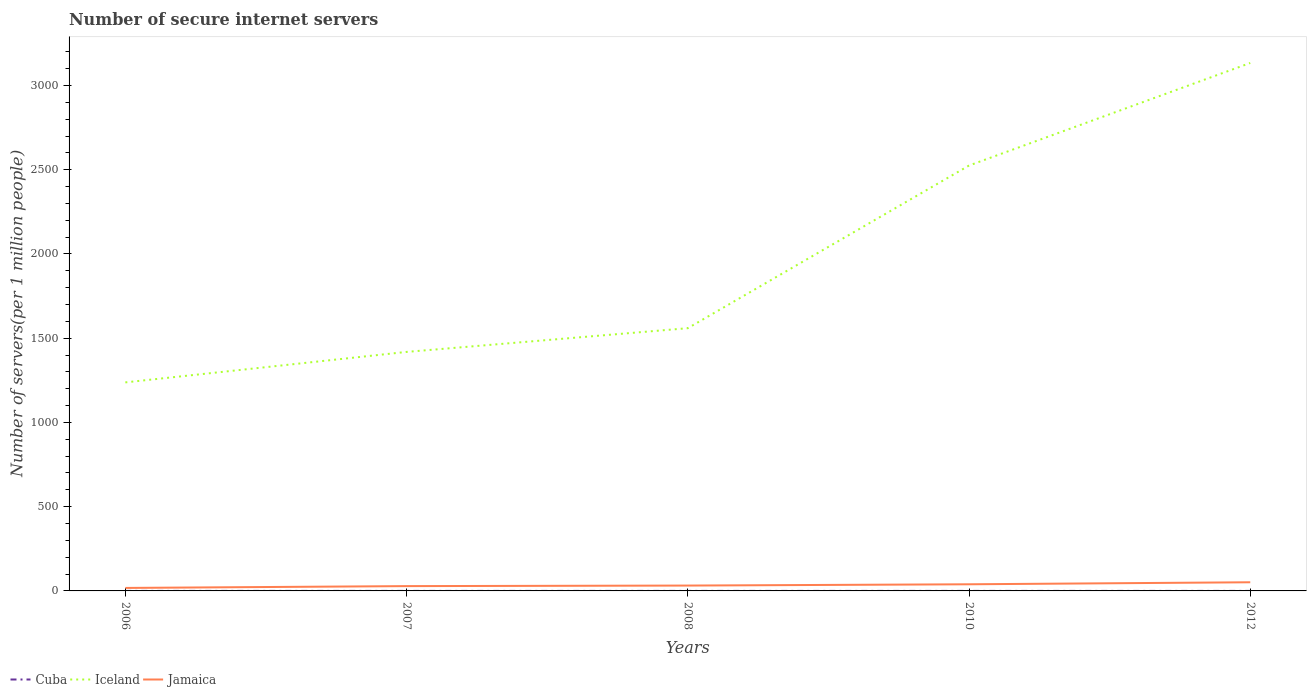How many different coloured lines are there?
Make the answer very short. 3. Is the number of lines equal to the number of legend labels?
Your answer should be compact. Yes. Across all years, what is the maximum number of secure internet servers in Iceland?
Keep it short and to the point. 1237.73. What is the total number of secure internet servers in Jamaica in the graph?
Your response must be concise. -3.27. What is the difference between the highest and the second highest number of secure internet servers in Cuba?
Provide a succinct answer. 0. What is the difference between two consecutive major ticks on the Y-axis?
Provide a short and direct response. 500. Where does the legend appear in the graph?
Keep it short and to the point. Bottom left. How are the legend labels stacked?
Ensure brevity in your answer.  Horizontal. What is the title of the graph?
Make the answer very short. Number of secure internet servers. What is the label or title of the Y-axis?
Your answer should be compact. Number of servers(per 1 million people). What is the Number of servers(per 1 million people) in Cuba in 2006?
Your answer should be compact. 0.09. What is the Number of servers(per 1 million people) in Iceland in 2006?
Offer a terse response. 1237.73. What is the Number of servers(per 1 million people) of Jamaica in 2006?
Your answer should be very brief. 17.72. What is the Number of servers(per 1 million people) in Cuba in 2007?
Give a very brief answer. 0.09. What is the Number of servers(per 1 million people) of Iceland in 2007?
Offer a terse response. 1418.64. What is the Number of servers(per 1 million people) of Jamaica in 2007?
Your answer should be very brief. 28.54. What is the Number of servers(per 1 million people) in Cuba in 2008?
Your answer should be very brief. 0.09. What is the Number of servers(per 1 million people) of Iceland in 2008?
Keep it short and to the point. 1559.48. What is the Number of servers(per 1 million people) in Jamaica in 2008?
Make the answer very short. 31.81. What is the Number of servers(per 1 million people) of Cuba in 2010?
Your answer should be very brief. 0.09. What is the Number of servers(per 1 million people) of Iceland in 2010?
Your response must be concise. 2524.83. What is the Number of servers(per 1 million people) of Jamaica in 2010?
Make the answer very short. 39.39. What is the Number of servers(per 1 million people) of Cuba in 2012?
Give a very brief answer. 0.09. What is the Number of servers(per 1 million people) of Iceland in 2012?
Your answer should be compact. 3133.61. What is the Number of servers(per 1 million people) in Jamaica in 2012?
Provide a succinct answer. 51.33. Across all years, what is the maximum Number of servers(per 1 million people) in Cuba?
Provide a short and direct response. 0.09. Across all years, what is the maximum Number of servers(per 1 million people) in Iceland?
Offer a very short reply. 3133.61. Across all years, what is the maximum Number of servers(per 1 million people) of Jamaica?
Your answer should be compact. 51.33. Across all years, what is the minimum Number of servers(per 1 million people) of Cuba?
Your answer should be very brief. 0.09. Across all years, what is the minimum Number of servers(per 1 million people) of Iceland?
Provide a short and direct response. 1237.73. Across all years, what is the minimum Number of servers(per 1 million people) of Jamaica?
Offer a terse response. 17.72. What is the total Number of servers(per 1 million people) of Cuba in the graph?
Give a very brief answer. 0.44. What is the total Number of servers(per 1 million people) of Iceland in the graph?
Give a very brief answer. 9874.29. What is the total Number of servers(per 1 million people) in Jamaica in the graph?
Your answer should be very brief. 168.8. What is the difference between the Number of servers(per 1 million people) in Cuba in 2006 and that in 2007?
Your answer should be compact. 0. What is the difference between the Number of servers(per 1 million people) in Iceland in 2006 and that in 2007?
Keep it short and to the point. -180.91. What is the difference between the Number of servers(per 1 million people) in Jamaica in 2006 and that in 2007?
Your response must be concise. -10.83. What is the difference between the Number of servers(per 1 million people) in Iceland in 2006 and that in 2008?
Your answer should be very brief. -321.75. What is the difference between the Number of servers(per 1 million people) of Jamaica in 2006 and that in 2008?
Ensure brevity in your answer.  -14.1. What is the difference between the Number of servers(per 1 million people) in Iceland in 2006 and that in 2010?
Offer a terse response. -1287.1. What is the difference between the Number of servers(per 1 million people) of Jamaica in 2006 and that in 2010?
Make the answer very short. -21.68. What is the difference between the Number of servers(per 1 million people) in Cuba in 2006 and that in 2012?
Your response must be concise. 0. What is the difference between the Number of servers(per 1 million people) in Iceland in 2006 and that in 2012?
Your answer should be compact. -1895.88. What is the difference between the Number of servers(per 1 million people) in Jamaica in 2006 and that in 2012?
Ensure brevity in your answer.  -33.62. What is the difference between the Number of servers(per 1 million people) in Cuba in 2007 and that in 2008?
Give a very brief answer. 0. What is the difference between the Number of servers(per 1 million people) of Iceland in 2007 and that in 2008?
Ensure brevity in your answer.  -140.84. What is the difference between the Number of servers(per 1 million people) of Jamaica in 2007 and that in 2008?
Provide a short and direct response. -3.27. What is the difference between the Number of servers(per 1 million people) of Cuba in 2007 and that in 2010?
Make the answer very short. 0. What is the difference between the Number of servers(per 1 million people) in Iceland in 2007 and that in 2010?
Ensure brevity in your answer.  -1106.19. What is the difference between the Number of servers(per 1 million people) of Jamaica in 2007 and that in 2010?
Your answer should be compact. -10.85. What is the difference between the Number of servers(per 1 million people) of Cuba in 2007 and that in 2012?
Your answer should be very brief. 0. What is the difference between the Number of servers(per 1 million people) in Iceland in 2007 and that in 2012?
Ensure brevity in your answer.  -1714.97. What is the difference between the Number of servers(per 1 million people) in Jamaica in 2007 and that in 2012?
Offer a terse response. -22.79. What is the difference between the Number of servers(per 1 million people) of Cuba in 2008 and that in 2010?
Offer a very short reply. 0. What is the difference between the Number of servers(per 1 million people) in Iceland in 2008 and that in 2010?
Offer a very short reply. -965.35. What is the difference between the Number of servers(per 1 million people) in Jamaica in 2008 and that in 2010?
Make the answer very short. -7.58. What is the difference between the Number of servers(per 1 million people) in Cuba in 2008 and that in 2012?
Your answer should be compact. 0. What is the difference between the Number of servers(per 1 million people) of Iceland in 2008 and that in 2012?
Your answer should be very brief. -1574.14. What is the difference between the Number of servers(per 1 million people) in Jamaica in 2008 and that in 2012?
Keep it short and to the point. -19.52. What is the difference between the Number of servers(per 1 million people) of Iceland in 2010 and that in 2012?
Give a very brief answer. -608.78. What is the difference between the Number of servers(per 1 million people) of Jamaica in 2010 and that in 2012?
Your answer should be very brief. -11.94. What is the difference between the Number of servers(per 1 million people) of Cuba in 2006 and the Number of servers(per 1 million people) of Iceland in 2007?
Ensure brevity in your answer.  -1418.55. What is the difference between the Number of servers(per 1 million people) in Cuba in 2006 and the Number of servers(per 1 million people) in Jamaica in 2007?
Offer a very short reply. -28.46. What is the difference between the Number of servers(per 1 million people) in Iceland in 2006 and the Number of servers(per 1 million people) in Jamaica in 2007?
Keep it short and to the point. 1209.18. What is the difference between the Number of servers(per 1 million people) in Cuba in 2006 and the Number of servers(per 1 million people) in Iceland in 2008?
Make the answer very short. -1559.39. What is the difference between the Number of servers(per 1 million people) in Cuba in 2006 and the Number of servers(per 1 million people) in Jamaica in 2008?
Make the answer very short. -31.72. What is the difference between the Number of servers(per 1 million people) of Iceland in 2006 and the Number of servers(per 1 million people) of Jamaica in 2008?
Your response must be concise. 1205.92. What is the difference between the Number of servers(per 1 million people) in Cuba in 2006 and the Number of servers(per 1 million people) in Iceland in 2010?
Ensure brevity in your answer.  -2524.74. What is the difference between the Number of servers(per 1 million people) of Cuba in 2006 and the Number of servers(per 1 million people) of Jamaica in 2010?
Ensure brevity in your answer.  -39.3. What is the difference between the Number of servers(per 1 million people) in Iceland in 2006 and the Number of servers(per 1 million people) in Jamaica in 2010?
Offer a very short reply. 1198.34. What is the difference between the Number of servers(per 1 million people) in Cuba in 2006 and the Number of servers(per 1 million people) in Iceland in 2012?
Give a very brief answer. -3133.52. What is the difference between the Number of servers(per 1 million people) in Cuba in 2006 and the Number of servers(per 1 million people) in Jamaica in 2012?
Provide a succinct answer. -51.24. What is the difference between the Number of servers(per 1 million people) of Iceland in 2006 and the Number of servers(per 1 million people) of Jamaica in 2012?
Ensure brevity in your answer.  1186.4. What is the difference between the Number of servers(per 1 million people) of Cuba in 2007 and the Number of servers(per 1 million people) of Iceland in 2008?
Offer a terse response. -1559.39. What is the difference between the Number of servers(per 1 million people) in Cuba in 2007 and the Number of servers(per 1 million people) in Jamaica in 2008?
Offer a very short reply. -31.72. What is the difference between the Number of servers(per 1 million people) in Iceland in 2007 and the Number of servers(per 1 million people) in Jamaica in 2008?
Your answer should be very brief. 1386.83. What is the difference between the Number of servers(per 1 million people) in Cuba in 2007 and the Number of servers(per 1 million people) in Iceland in 2010?
Ensure brevity in your answer.  -2524.74. What is the difference between the Number of servers(per 1 million people) in Cuba in 2007 and the Number of servers(per 1 million people) in Jamaica in 2010?
Keep it short and to the point. -39.3. What is the difference between the Number of servers(per 1 million people) of Iceland in 2007 and the Number of servers(per 1 million people) of Jamaica in 2010?
Offer a very short reply. 1379.25. What is the difference between the Number of servers(per 1 million people) in Cuba in 2007 and the Number of servers(per 1 million people) in Iceland in 2012?
Make the answer very short. -3133.52. What is the difference between the Number of servers(per 1 million people) of Cuba in 2007 and the Number of servers(per 1 million people) of Jamaica in 2012?
Offer a terse response. -51.24. What is the difference between the Number of servers(per 1 million people) of Iceland in 2007 and the Number of servers(per 1 million people) of Jamaica in 2012?
Offer a very short reply. 1367.31. What is the difference between the Number of servers(per 1 million people) of Cuba in 2008 and the Number of servers(per 1 million people) of Iceland in 2010?
Ensure brevity in your answer.  -2524.74. What is the difference between the Number of servers(per 1 million people) of Cuba in 2008 and the Number of servers(per 1 million people) of Jamaica in 2010?
Give a very brief answer. -39.3. What is the difference between the Number of servers(per 1 million people) of Iceland in 2008 and the Number of servers(per 1 million people) of Jamaica in 2010?
Offer a terse response. 1520.08. What is the difference between the Number of servers(per 1 million people) of Cuba in 2008 and the Number of servers(per 1 million people) of Iceland in 2012?
Your answer should be very brief. -3133.53. What is the difference between the Number of servers(per 1 million people) in Cuba in 2008 and the Number of servers(per 1 million people) in Jamaica in 2012?
Your answer should be very brief. -51.24. What is the difference between the Number of servers(per 1 million people) of Iceland in 2008 and the Number of servers(per 1 million people) of Jamaica in 2012?
Make the answer very short. 1508.14. What is the difference between the Number of servers(per 1 million people) of Cuba in 2010 and the Number of servers(per 1 million people) of Iceland in 2012?
Keep it short and to the point. -3133.53. What is the difference between the Number of servers(per 1 million people) in Cuba in 2010 and the Number of servers(per 1 million people) in Jamaica in 2012?
Keep it short and to the point. -51.24. What is the difference between the Number of servers(per 1 million people) of Iceland in 2010 and the Number of servers(per 1 million people) of Jamaica in 2012?
Offer a very short reply. 2473.5. What is the average Number of servers(per 1 million people) in Cuba per year?
Offer a very short reply. 0.09. What is the average Number of servers(per 1 million people) of Iceland per year?
Your answer should be compact. 1974.86. What is the average Number of servers(per 1 million people) of Jamaica per year?
Provide a succinct answer. 33.76. In the year 2006, what is the difference between the Number of servers(per 1 million people) in Cuba and Number of servers(per 1 million people) in Iceland?
Your answer should be very brief. -1237.64. In the year 2006, what is the difference between the Number of servers(per 1 million people) in Cuba and Number of servers(per 1 million people) in Jamaica?
Make the answer very short. -17.63. In the year 2006, what is the difference between the Number of servers(per 1 million people) in Iceland and Number of servers(per 1 million people) in Jamaica?
Keep it short and to the point. 1220.01. In the year 2007, what is the difference between the Number of servers(per 1 million people) of Cuba and Number of servers(per 1 million people) of Iceland?
Offer a terse response. -1418.55. In the year 2007, what is the difference between the Number of servers(per 1 million people) in Cuba and Number of servers(per 1 million people) in Jamaica?
Provide a short and direct response. -28.46. In the year 2007, what is the difference between the Number of servers(per 1 million people) of Iceland and Number of servers(per 1 million people) of Jamaica?
Provide a succinct answer. 1390.1. In the year 2008, what is the difference between the Number of servers(per 1 million people) of Cuba and Number of servers(per 1 million people) of Iceland?
Your answer should be compact. -1559.39. In the year 2008, what is the difference between the Number of servers(per 1 million people) of Cuba and Number of servers(per 1 million people) of Jamaica?
Give a very brief answer. -31.72. In the year 2008, what is the difference between the Number of servers(per 1 million people) of Iceland and Number of servers(per 1 million people) of Jamaica?
Provide a short and direct response. 1527.67. In the year 2010, what is the difference between the Number of servers(per 1 million people) in Cuba and Number of servers(per 1 million people) in Iceland?
Your response must be concise. -2524.74. In the year 2010, what is the difference between the Number of servers(per 1 million people) in Cuba and Number of servers(per 1 million people) in Jamaica?
Your answer should be compact. -39.3. In the year 2010, what is the difference between the Number of servers(per 1 million people) of Iceland and Number of servers(per 1 million people) of Jamaica?
Offer a terse response. 2485.44. In the year 2012, what is the difference between the Number of servers(per 1 million people) of Cuba and Number of servers(per 1 million people) of Iceland?
Make the answer very short. -3133.53. In the year 2012, what is the difference between the Number of servers(per 1 million people) in Cuba and Number of servers(per 1 million people) in Jamaica?
Your answer should be very brief. -51.24. In the year 2012, what is the difference between the Number of servers(per 1 million people) in Iceland and Number of servers(per 1 million people) in Jamaica?
Give a very brief answer. 3082.28. What is the ratio of the Number of servers(per 1 million people) of Iceland in 2006 to that in 2007?
Your answer should be compact. 0.87. What is the ratio of the Number of servers(per 1 million people) of Jamaica in 2006 to that in 2007?
Offer a terse response. 0.62. What is the ratio of the Number of servers(per 1 million people) in Iceland in 2006 to that in 2008?
Ensure brevity in your answer.  0.79. What is the ratio of the Number of servers(per 1 million people) in Jamaica in 2006 to that in 2008?
Keep it short and to the point. 0.56. What is the ratio of the Number of servers(per 1 million people) in Cuba in 2006 to that in 2010?
Provide a succinct answer. 1. What is the ratio of the Number of servers(per 1 million people) in Iceland in 2006 to that in 2010?
Offer a very short reply. 0.49. What is the ratio of the Number of servers(per 1 million people) of Jamaica in 2006 to that in 2010?
Your answer should be compact. 0.45. What is the ratio of the Number of servers(per 1 million people) in Cuba in 2006 to that in 2012?
Give a very brief answer. 1.01. What is the ratio of the Number of servers(per 1 million people) of Iceland in 2006 to that in 2012?
Offer a terse response. 0.4. What is the ratio of the Number of servers(per 1 million people) of Jamaica in 2006 to that in 2012?
Provide a succinct answer. 0.35. What is the ratio of the Number of servers(per 1 million people) of Cuba in 2007 to that in 2008?
Your response must be concise. 1. What is the ratio of the Number of servers(per 1 million people) in Iceland in 2007 to that in 2008?
Your response must be concise. 0.91. What is the ratio of the Number of servers(per 1 million people) in Jamaica in 2007 to that in 2008?
Your answer should be very brief. 0.9. What is the ratio of the Number of servers(per 1 million people) in Iceland in 2007 to that in 2010?
Give a very brief answer. 0.56. What is the ratio of the Number of servers(per 1 million people) of Jamaica in 2007 to that in 2010?
Provide a succinct answer. 0.72. What is the ratio of the Number of servers(per 1 million people) of Iceland in 2007 to that in 2012?
Your response must be concise. 0.45. What is the ratio of the Number of servers(per 1 million people) in Jamaica in 2007 to that in 2012?
Your response must be concise. 0.56. What is the ratio of the Number of servers(per 1 million people) of Cuba in 2008 to that in 2010?
Provide a short and direct response. 1. What is the ratio of the Number of servers(per 1 million people) in Iceland in 2008 to that in 2010?
Provide a short and direct response. 0.62. What is the ratio of the Number of servers(per 1 million people) of Jamaica in 2008 to that in 2010?
Make the answer very short. 0.81. What is the ratio of the Number of servers(per 1 million people) in Iceland in 2008 to that in 2012?
Keep it short and to the point. 0.5. What is the ratio of the Number of servers(per 1 million people) in Jamaica in 2008 to that in 2012?
Offer a very short reply. 0.62. What is the ratio of the Number of servers(per 1 million people) of Iceland in 2010 to that in 2012?
Provide a succinct answer. 0.81. What is the ratio of the Number of servers(per 1 million people) of Jamaica in 2010 to that in 2012?
Give a very brief answer. 0.77. What is the difference between the highest and the second highest Number of servers(per 1 million people) of Cuba?
Your response must be concise. 0. What is the difference between the highest and the second highest Number of servers(per 1 million people) in Iceland?
Provide a short and direct response. 608.78. What is the difference between the highest and the second highest Number of servers(per 1 million people) in Jamaica?
Provide a short and direct response. 11.94. What is the difference between the highest and the lowest Number of servers(per 1 million people) of Cuba?
Your answer should be very brief. 0. What is the difference between the highest and the lowest Number of servers(per 1 million people) in Iceland?
Ensure brevity in your answer.  1895.88. What is the difference between the highest and the lowest Number of servers(per 1 million people) of Jamaica?
Offer a terse response. 33.62. 